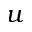Convert formula to latex. <formula><loc_0><loc_0><loc_500><loc_500>u</formula> 